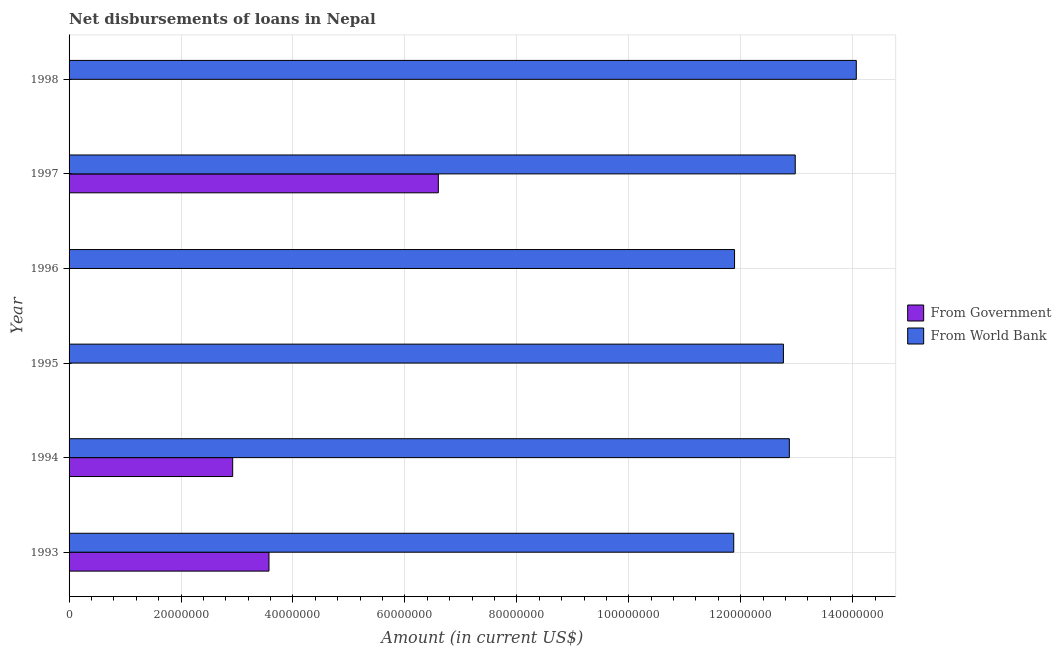How many different coloured bars are there?
Ensure brevity in your answer.  2. Are the number of bars per tick equal to the number of legend labels?
Your response must be concise. No. Are the number of bars on each tick of the Y-axis equal?
Make the answer very short. No. What is the net disbursements of loan from government in 1997?
Ensure brevity in your answer.  6.60e+07. Across all years, what is the maximum net disbursements of loan from government?
Provide a short and direct response. 6.60e+07. What is the total net disbursements of loan from world bank in the graph?
Your answer should be compact. 7.64e+08. What is the difference between the net disbursements of loan from world bank in 1995 and that in 1997?
Offer a very short reply. -2.11e+06. What is the difference between the net disbursements of loan from world bank in 1996 and the net disbursements of loan from government in 1994?
Provide a succinct answer. 8.97e+07. What is the average net disbursements of loan from world bank per year?
Make the answer very short. 1.27e+08. In the year 1993, what is the difference between the net disbursements of loan from government and net disbursements of loan from world bank?
Offer a terse response. -8.30e+07. In how many years, is the net disbursements of loan from government greater than 20000000 US$?
Ensure brevity in your answer.  3. Is the net disbursements of loan from government in 1993 less than that in 1997?
Keep it short and to the point. Yes. What is the difference between the highest and the second highest net disbursements of loan from government?
Provide a short and direct response. 3.03e+07. What is the difference between the highest and the lowest net disbursements of loan from world bank?
Offer a terse response. 2.19e+07. How many bars are there?
Your answer should be very brief. 9. What is the difference between two consecutive major ticks on the X-axis?
Keep it short and to the point. 2.00e+07. Are the values on the major ticks of X-axis written in scientific E-notation?
Provide a succinct answer. No. Does the graph contain grids?
Keep it short and to the point. Yes. Where does the legend appear in the graph?
Give a very brief answer. Center right. How are the legend labels stacked?
Provide a short and direct response. Vertical. What is the title of the graph?
Ensure brevity in your answer.  Net disbursements of loans in Nepal. What is the label or title of the Y-axis?
Provide a short and direct response. Year. What is the Amount (in current US$) in From Government in 1993?
Your answer should be compact. 3.57e+07. What is the Amount (in current US$) of From World Bank in 1993?
Offer a terse response. 1.19e+08. What is the Amount (in current US$) of From Government in 1994?
Ensure brevity in your answer.  2.92e+07. What is the Amount (in current US$) of From World Bank in 1994?
Provide a succinct answer. 1.29e+08. What is the Amount (in current US$) of From Government in 1995?
Give a very brief answer. 0. What is the Amount (in current US$) of From World Bank in 1995?
Keep it short and to the point. 1.28e+08. What is the Amount (in current US$) of From World Bank in 1996?
Ensure brevity in your answer.  1.19e+08. What is the Amount (in current US$) of From Government in 1997?
Provide a short and direct response. 6.60e+07. What is the Amount (in current US$) in From World Bank in 1997?
Provide a succinct answer. 1.30e+08. What is the Amount (in current US$) in From Government in 1998?
Provide a short and direct response. 0. What is the Amount (in current US$) in From World Bank in 1998?
Your answer should be very brief. 1.41e+08. Across all years, what is the maximum Amount (in current US$) of From Government?
Your answer should be very brief. 6.60e+07. Across all years, what is the maximum Amount (in current US$) of From World Bank?
Provide a short and direct response. 1.41e+08. Across all years, what is the minimum Amount (in current US$) in From World Bank?
Your response must be concise. 1.19e+08. What is the total Amount (in current US$) of From Government in the graph?
Offer a very short reply. 1.31e+08. What is the total Amount (in current US$) of From World Bank in the graph?
Provide a succinct answer. 7.64e+08. What is the difference between the Amount (in current US$) in From Government in 1993 and that in 1994?
Offer a very short reply. 6.48e+06. What is the difference between the Amount (in current US$) in From World Bank in 1993 and that in 1994?
Provide a succinct answer. -9.94e+06. What is the difference between the Amount (in current US$) in From World Bank in 1993 and that in 1995?
Provide a succinct answer. -8.88e+06. What is the difference between the Amount (in current US$) of From World Bank in 1993 and that in 1996?
Give a very brief answer. -1.45e+05. What is the difference between the Amount (in current US$) of From Government in 1993 and that in 1997?
Offer a terse response. -3.03e+07. What is the difference between the Amount (in current US$) of From World Bank in 1993 and that in 1997?
Your response must be concise. -1.10e+07. What is the difference between the Amount (in current US$) of From World Bank in 1993 and that in 1998?
Offer a very short reply. -2.19e+07. What is the difference between the Amount (in current US$) in From World Bank in 1994 and that in 1995?
Ensure brevity in your answer.  1.06e+06. What is the difference between the Amount (in current US$) in From World Bank in 1994 and that in 1996?
Ensure brevity in your answer.  9.79e+06. What is the difference between the Amount (in current US$) in From Government in 1994 and that in 1997?
Keep it short and to the point. -3.67e+07. What is the difference between the Amount (in current US$) in From World Bank in 1994 and that in 1997?
Provide a short and direct response. -1.06e+06. What is the difference between the Amount (in current US$) of From World Bank in 1994 and that in 1998?
Keep it short and to the point. -1.20e+07. What is the difference between the Amount (in current US$) in From World Bank in 1995 and that in 1996?
Offer a terse response. 8.73e+06. What is the difference between the Amount (in current US$) in From World Bank in 1995 and that in 1997?
Ensure brevity in your answer.  -2.11e+06. What is the difference between the Amount (in current US$) in From World Bank in 1995 and that in 1998?
Offer a very short reply. -1.30e+07. What is the difference between the Amount (in current US$) of From World Bank in 1996 and that in 1997?
Provide a succinct answer. -1.08e+07. What is the difference between the Amount (in current US$) of From World Bank in 1996 and that in 1998?
Your answer should be very brief. -2.18e+07. What is the difference between the Amount (in current US$) in From World Bank in 1997 and that in 1998?
Offer a terse response. -1.09e+07. What is the difference between the Amount (in current US$) of From Government in 1993 and the Amount (in current US$) of From World Bank in 1994?
Provide a succinct answer. -9.30e+07. What is the difference between the Amount (in current US$) in From Government in 1993 and the Amount (in current US$) in From World Bank in 1995?
Offer a terse response. -9.19e+07. What is the difference between the Amount (in current US$) of From Government in 1993 and the Amount (in current US$) of From World Bank in 1996?
Offer a terse response. -8.32e+07. What is the difference between the Amount (in current US$) in From Government in 1993 and the Amount (in current US$) in From World Bank in 1997?
Provide a short and direct response. -9.40e+07. What is the difference between the Amount (in current US$) of From Government in 1993 and the Amount (in current US$) of From World Bank in 1998?
Your answer should be compact. -1.05e+08. What is the difference between the Amount (in current US$) in From Government in 1994 and the Amount (in current US$) in From World Bank in 1995?
Offer a very short reply. -9.84e+07. What is the difference between the Amount (in current US$) in From Government in 1994 and the Amount (in current US$) in From World Bank in 1996?
Provide a succinct answer. -8.97e+07. What is the difference between the Amount (in current US$) in From Government in 1994 and the Amount (in current US$) in From World Bank in 1997?
Make the answer very short. -1.01e+08. What is the difference between the Amount (in current US$) of From Government in 1994 and the Amount (in current US$) of From World Bank in 1998?
Make the answer very short. -1.11e+08. What is the difference between the Amount (in current US$) of From Government in 1997 and the Amount (in current US$) of From World Bank in 1998?
Provide a succinct answer. -7.47e+07. What is the average Amount (in current US$) in From Government per year?
Your response must be concise. 2.18e+07. What is the average Amount (in current US$) of From World Bank per year?
Keep it short and to the point. 1.27e+08. In the year 1993, what is the difference between the Amount (in current US$) of From Government and Amount (in current US$) of From World Bank?
Keep it short and to the point. -8.30e+07. In the year 1994, what is the difference between the Amount (in current US$) of From Government and Amount (in current US$) of From World Bank?
Your answer should be compact. -9.95e+07. In the year 1997, what is the difference between the Amount (in current US$) in From Government and Amount (in current US$) in From World Bank?
Offer a terse response. -6.38e+07. What is the ratio of the Amount (in current US$) in From Government in 1993 to that in 1994?
Give a very brief answer. 1.22. What is the ratio of the Amount (in current US$) of From World Bank in 1993 to that in 1994?
Keep it short and to the point. 0.92. What is the ratio of the Amount (in current US$) in From World Bank in 1993 to that in 1995?
Your answer should be very brief. 0.93. What is the ratio of the Amount (in current US$) in From World Bank in 1993 to that in 1996?
Give a very brief answer. 1. What is the ratio of the Amount (in current US$) in From Government in 1993 to that in 1997?
Give a very brief answer. 0.54. What is the ratio of the Amount (in current US$) of From World Bank in 1993 to that in 1997?
Ensure brevity in your answer.  0.92. What is the ratio of the Amount (in current US$) of From World Bank in 1993 to that in 1998?
Provide a short and direct response. 0.84. What is the ratio of the Amount (in current US$) in From World Bank in 1994 to that in 1995?
Your answer should be compact. 1.01. What is the ratio of the Amount (in current US$) in From World Bank in 1994 to that in 1996?
Offer a very short reply. 1.08. What is the ratio of the Amount (in current US$) of From Government in 1994 to that in 1997?
Ensure brevity in your answer.  0.44. What is the ratio of the Amount (in current US$) of From World Bank in 1994 to that in 1997?
Offer a terse response. 0.99. What is the ratio of the Amount (in current US$) of From World Bank in 1994 to that in 1998?
Your answer should be compact. 0.91. What is the ratio of the Amount (in current US$) in From World Bank in 1995 to that in 1996?
Keep it short and to the point. 1.07. What is the ratio of the Amount (in current US$) in From World Bank in 1995 to that in 1997?
Make the answer very short. 0.98. What is the ratio of the Amount (in current US$) in From World Bank in 1995 to that in 1998?
Give a very brief answer. 0.91. What is the ratio of the Amount (in current US$) of From World Bank in 1996 to that in 1997?
Your response must be concise. 0.92. What is the ratio of the Amount (in current US$) in From World Bank in 1996 to that in 1998?
Give a very brief answer. 0.85. What is the ratio of the Amount (in current US$) in From World Bank in 1997 to that in 1998?
Make the answer very short. 0.92. What is the difference between the highest and the second highest Amount (in current US$) of From Government?
Keep it short and to the point. 3.03e+07. What is the difference between the highest and the second highest Amount (in current US$) in From World Bank?
Give a very brief answer. 1.09e+07. What is the difference between the highest and the lowest Amount (in current US$) in From Government?
Your answer should be very brief. 6.60e+07. What is the difference between the highest and the lowest Amount (in current US$) in From World Bank?
Offer a terse response. 2.19e+07. 